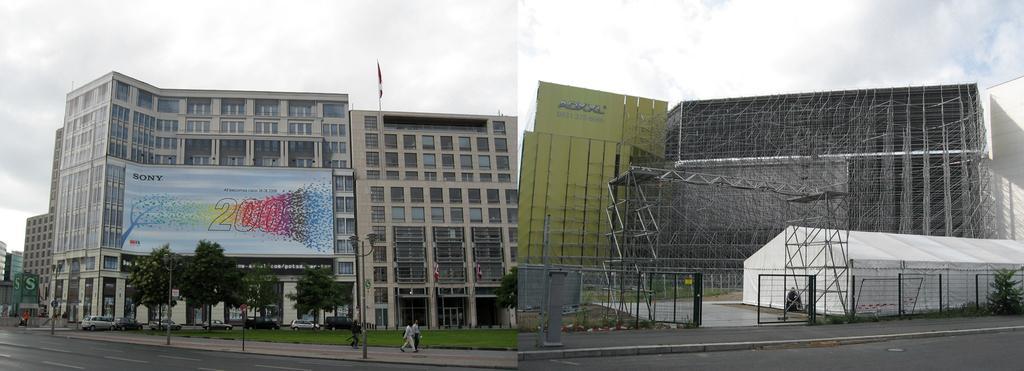Describe this image in one or two sentences. It is an collage picture. In this picture this building is before construction, this building is after construction. The sky is cloudy. Before this building there is a banner. There are number of trees. Far there are number of buildings. In-front this building there are number of vehicles and grass. Persons are walking on footpath, as there is a movement in there legs. Poles are far away from each other. 